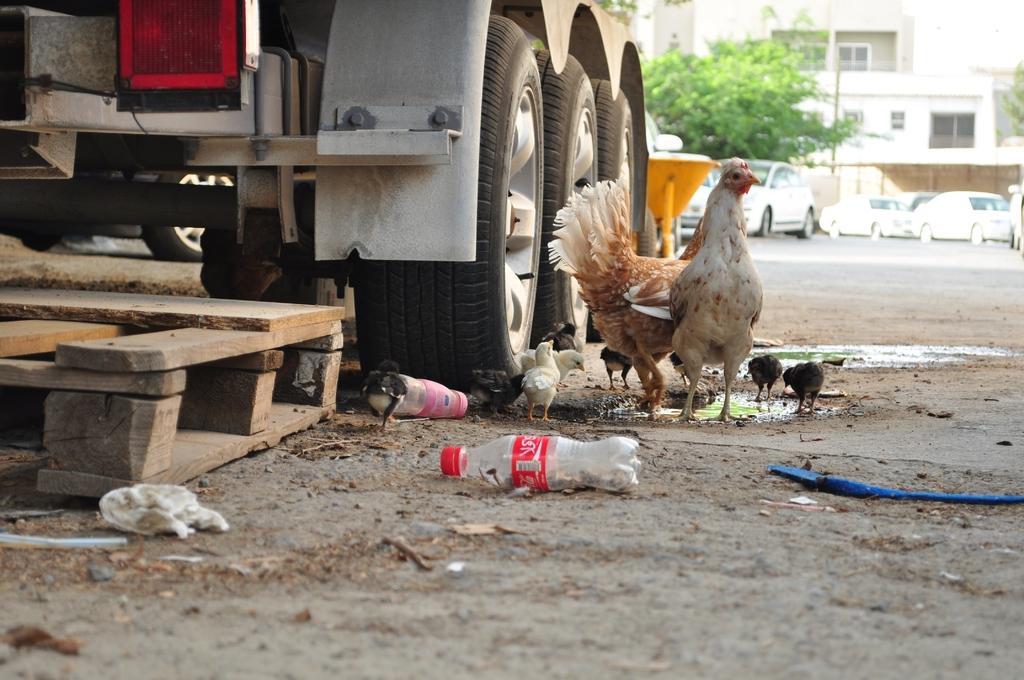Please provide a concise description of this image. In this image there is hen, chicks, water bottle, in the road, truck, car, tree, pole,building , sky, wooden steps. 